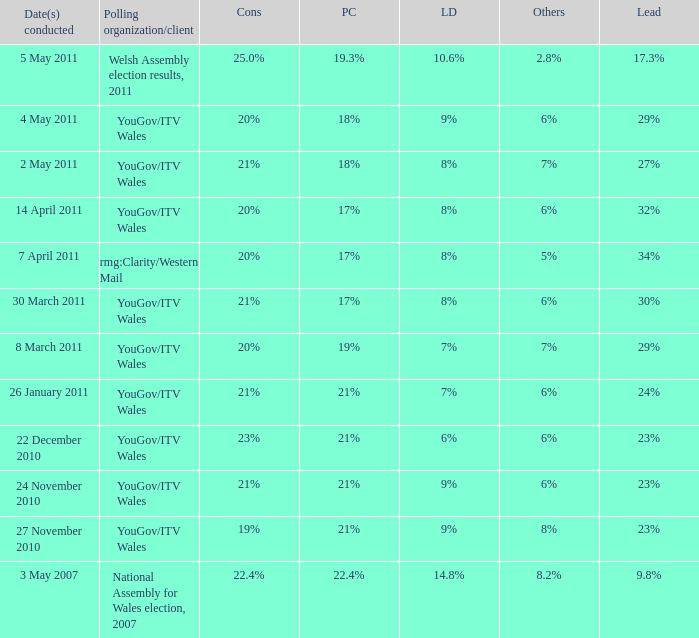What is the cons for lib dem of 8% and a lead of 27% 21%. 